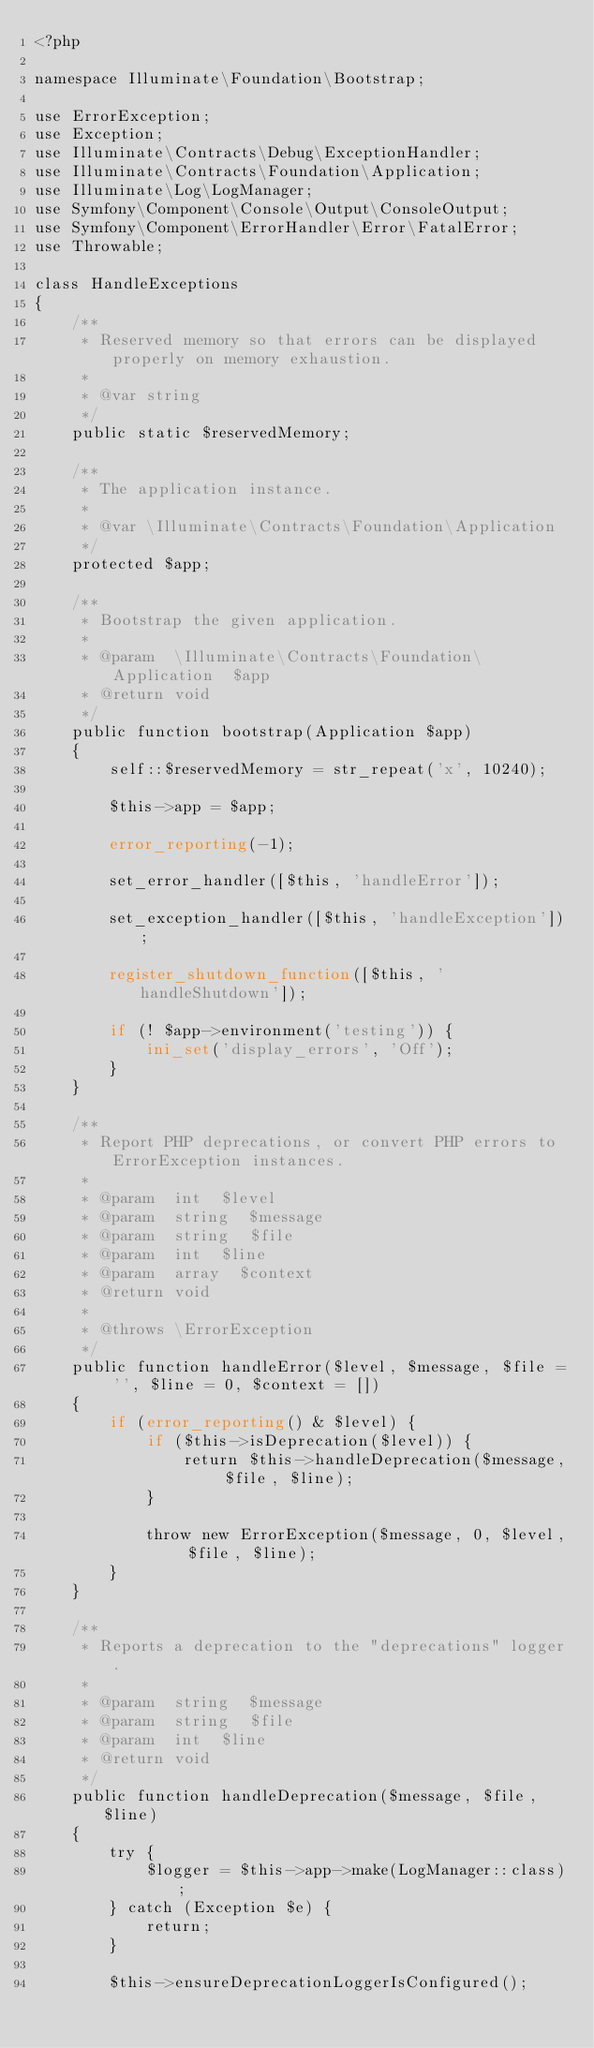Convert code to text. <code><loc_0><loc_0><loc_500><loc_500><_PHP_><?php

namespace Illuminate\Foundation\Bootstrap;

use ErrorException;
use Exception;
use Illuminate\Contracts\Debug\ExceptionHandler;
use Illuminate\Contracts\Foundation\Application;
use Illuminate\Log\LogManager;
use Symfony\Component\Console\Output\ConsoleOutput;
use Symfony\Component\ErrorHandler\Error\FatalError;
use Throwable;

class HandleExceptions
{
    /**
     * Reserved memory so that errors can be displayed properly on memory exhaustion.
     *
     * @var string
     */
    public static $reservedMemory;

    /**
     * The application instance.
     *
     * @var \Illuminate\Contracts\Foundation\Application
     */
    protected $app;

    /**
     * Bootstrap the given application.
     *
     * @param  \Illuminate\Contracts\Foundation\Application  $app
     * @return void
     */
    public function bootstrap(Application $app)
    {
        self::$reservedMemory = str_repeat('x', 10240);

        $this->app = $app;

        error_reporting(-1);

        set_error_handler([$this, 'handleError']);

        set_exception_handler([$this, 'handleException']);

        register_shutdown_function([$this, 'handleShutdown']);

        if (! $app->environment('testing')) {
            ini_set('display_errors', 'Off');
        }
    }

    /**
     * Report PHP deprecations, or convert PHP errors to ErrorException instances.
     *
     * @param  int  $level
     * @param  string  $message
     * @param  string  $file
     * @param  int  $line
     * @param  array  $context
     * @return void
     *
     * @throws \ErrorException
     */
    public function handleError($level, $message, $file = '', $line = 0, $context = [])
    {
        if (error_reporting() & $level) {
            if ($this->isDeprecation($level)) {
                return $this->handleDeprecation($message, $file, $line);
            }

            throw new ErrorException($message, 0, $level, $file, $line);
        }
    }

    /**
     * Reports a deprecation to the "deprecations" logger.
     *
     * @param  string  $message
     * @param  string  $file
     * @param  int  $line
     * @return void
     */
    public function handleDeprecation($message, $file, $line)
    {
        try {
            $logger = $this->app->make(LogManager::class);
        } catch (Exception $e) {
            return;
        }

        $this->ensureDeprecationLoggerIsConfigured();
</code> 